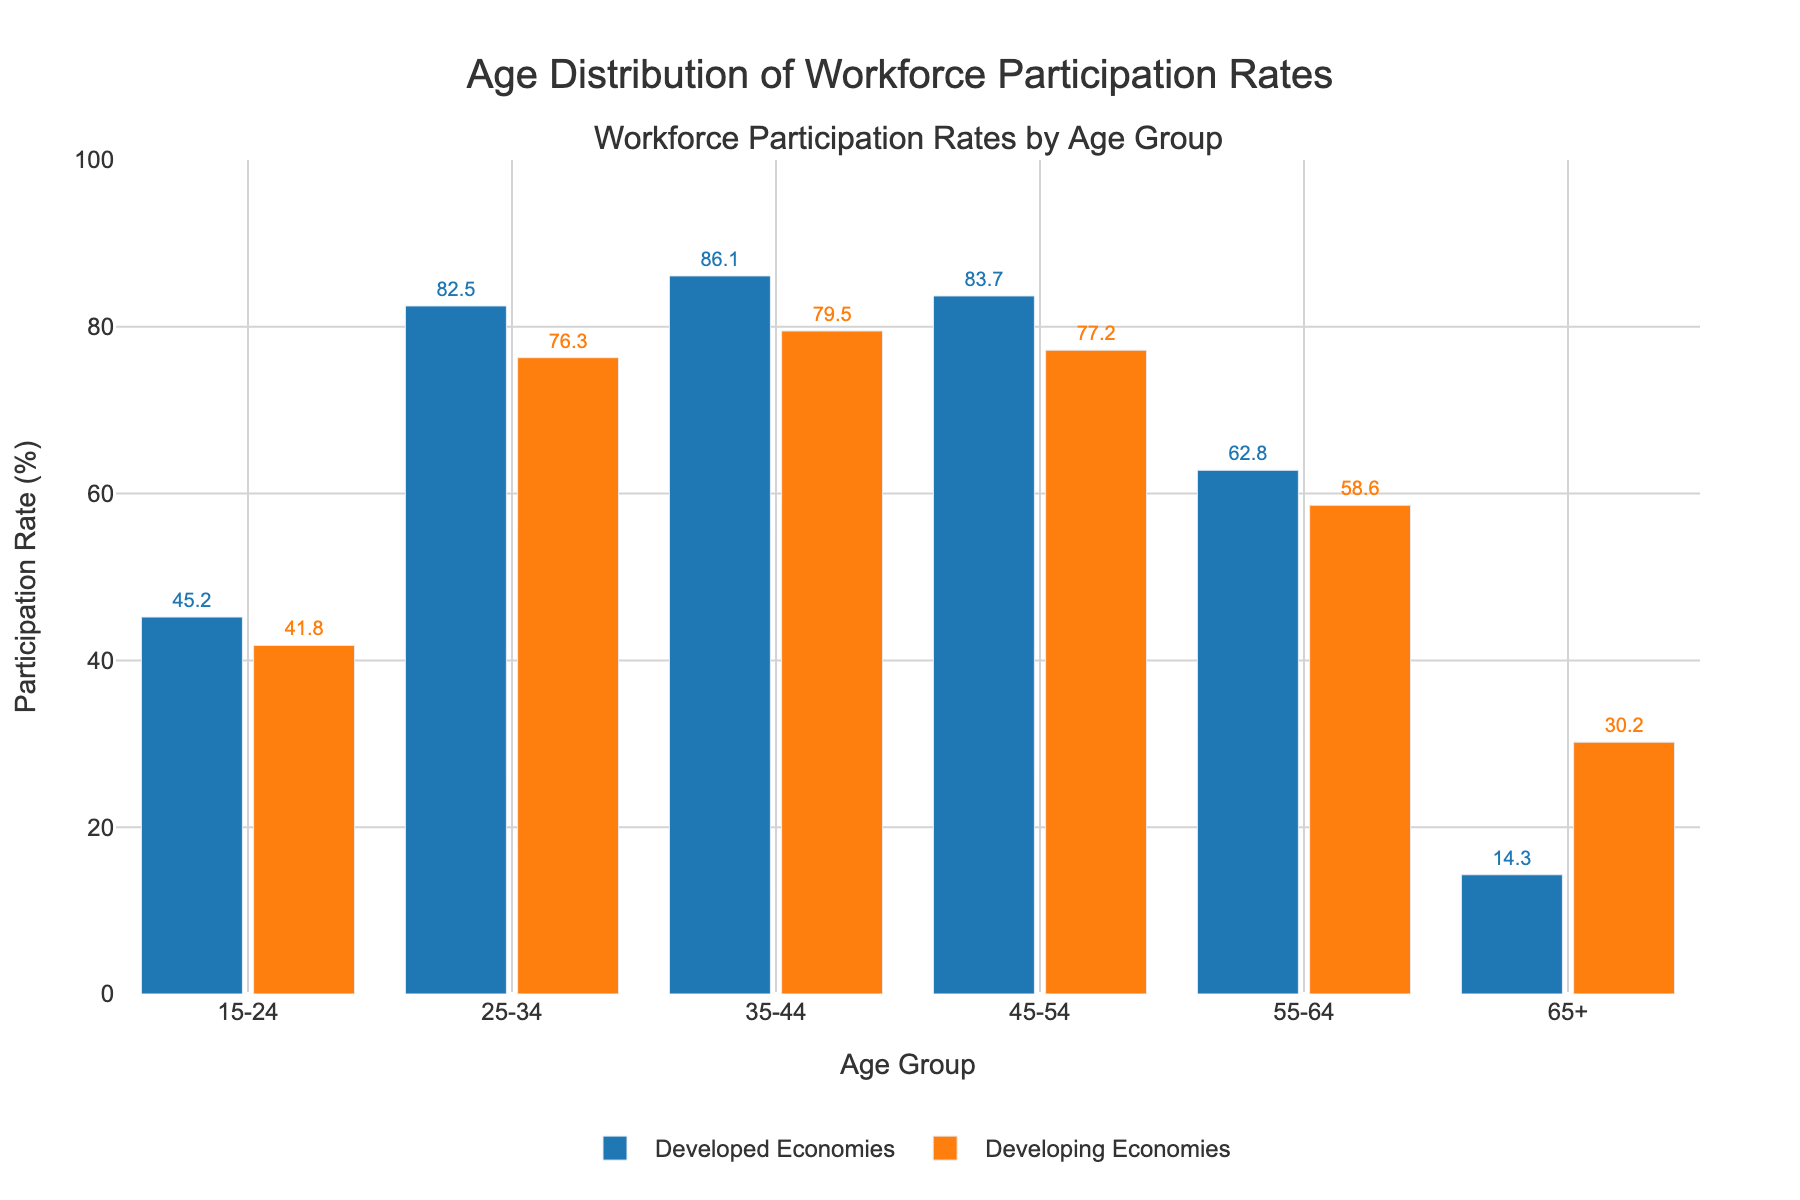Which age group has the highest workforce participation rate in developed economies? The bar for the 35-44 age group is the tallest among developed economies, indicating the highest participation rate.
Answer: 35-44 age group Which age group has the lowest workforce participation rate in developing economies? The bar for the 15-24 age group is the shortest among developing economies, indicating the lowest participation rate.
Answer: 15-24 age group How does the workforce participation rate for the 65+ age group compare between developed and developing economies? The bar for the 65+ age group in developing economies is significantly taller than the bar for the same age group in developed economies. Therefore, the participation rate is higher in developing economies.
Answer: Higher in developing economies What is the difference in workforce participation rates between the 25-34 and 55-64 age groups in developed economies? The participation rate for the 25-34 age group is 82.5%, and for the 55-64 age group, it is 62.8%. The difference is 82.5% - 62.8%.
Answer: 19.7% Which economy sees a greater drop in workforce participation rates from the 45-54 to the 55-64 age group? In developed economies, the drop is from 83.7% to 62.8% (a difference of 20.9%). In developing economies, the drop is from 77.2% to 58.6% (a difference of 18.6%). Thus, the drop is greater in developed economies.
Answer: Developed economies Across all age groups, which economy has more consistent participation rates? By visually inspecting the heights of the bars, it appears that developed economies have more consistent heights across age groups compared to the more varied heights in developing economies.
Answer: Developed economies What is the average workforce participation rate for the 15-24 and 65+ age groups in developing economies? The rates for these groups are 41.8% and 30.2%. The average is calculated as (41.8 + 30.2) / 2.
Answer: 36% Comparing the 35-44 age group workforce participation rates, how many percentage points higher is the developed economies' rate compared to the developing economies' rate? The participation rate for the 35-44 age group in developed economies is 86.1%, while in developing economies, it is 79.5%. The difference is 86.1% - 79.5%.
Answer: 6.6% In which age group do developed and developing economies have the smallest difference in workforce participation rates? By examining the bar heights, the 15-24 age group has the smallest difference, with rates of 45.2% and 41.8% respectively. The difference is 45.2% - 41.8%.
Answer: 3.4% 